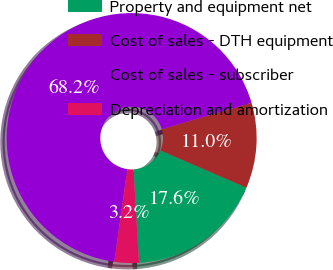<chart> <loc_0><loc_0><loc_500><loc_500><pie_chart><fcel>Property and equipment net<fcel>Cost of sales - DTH equipment<fcel>Cost of sales - subscriber<fcel>Depreciation and amortization<nl><fcel>17.56%<fcel>11.05%<fcel>68.23%<fcel>3.16%<nl></chart> 